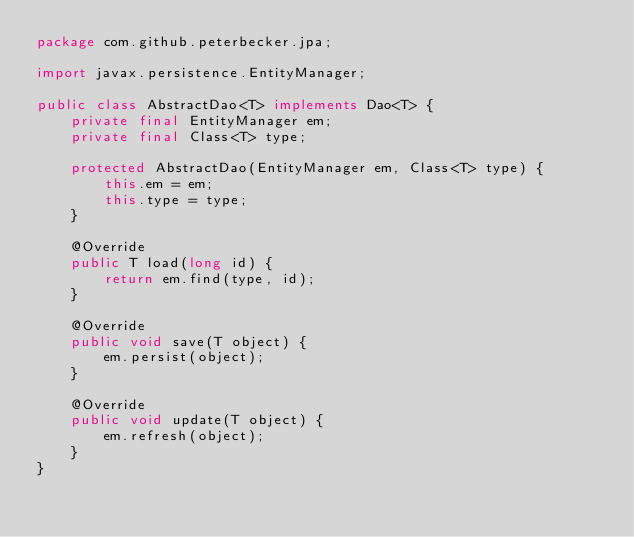Convert code to text. <code><loc_0><loc_0><loc_500><loc_500><_Java_>package com.github.peterbecker.jpa;

import javax.persistence.EntityManager;

public class AbstractDao<T> implements Dao<T> {
    private final EntityManager em;
    private final Class<T> type;

    protected AbstractDao(EntityManager em, Class<T> type) {
        this.em = em;
        this.type = type;
    }

    @Override
    public T load(long id) {
        return em.find(type, id);
    }

    @Override
    public void save(T object) {
        em.persist(object);
    }

    @Override
    public void update(T object) {
        em.refresh(object);
    }
}
</code> 